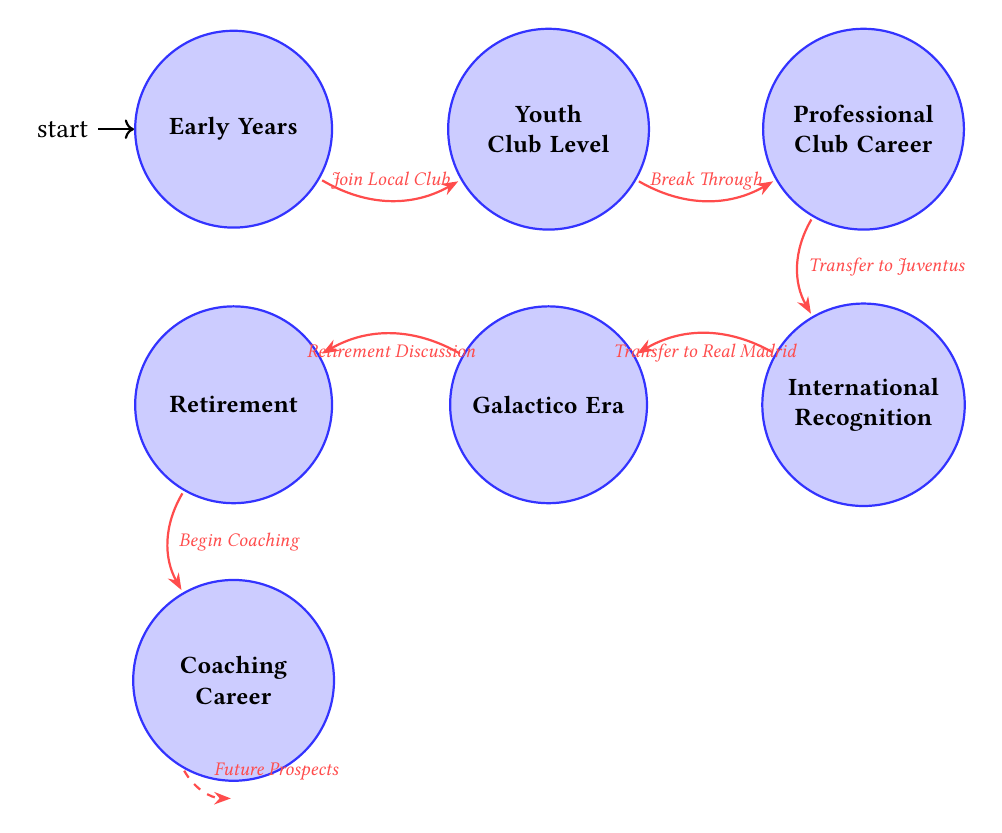What is the first state in the diagram? The first state in the diagram is the initial node, which is labeled "Early Years." This can be determined by visually identifying the node that does not have any incoming edges.
Answer: Early Years How many total states are present in the diagram? To determine the total number of states, count the individual nodes depicted in the diagram. There are seven nodes: Early Years, Youth Club Level, Professional Club Career, International Recognition, Galactico Era, Retirement, and Coaching Career.
Answer: 7 What event triggers the transition from Youth Club Level to Professional Club Career? The transition from Youth Club Level to Professional Club Career occurs after the event "Break Through," as indicated by the edge connecting these two states with this specific label.
Answer: Break Through What is the last state before the Coaching Career? The last state before Coaching Career is "Retirement." This can be determined by identifying the node that directly connects to Coaching Career in the diagram.
Answer: Retirement Which state signifies Zidane's peak fame in club football? The state that signifies Zidane's peak fame in club football is "International Recognition." This state represents his achievements and fame while playing for Juventus, as depicted in the diagram.
Answer: International Recognition What transition occurs after Zidane discusses retirement? After Zidane discusses retirement, the transition leads to the state "Retirement." This is indicated by the edge labeled "Retirement Discussion" that connects to the Retirement state.
Answer: Retirement What significant event happens when Zidane transfers to Juventus? When Zidane transfers to Juventus, it marks the transition to "International Recognition," which is indicated by the edge labeled "Transfer to Juventus." This transition highlights a key moment in his career.
Answer: International Recognition In which state does Zidane start managing a team? Zidane starts managing a team in the state labeled "Coaching Career." This state follows his retirement from professional football and illustrates his new role as a coach.
Answer: Coaching Career 